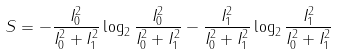<formula> <loc_0><loc_0><loc_500><loc_500>S = - \frac { I ^ { 2 } _ { 0 } } { I ^ { 2 } _ { 0 } + I ^ { 2 } _ { 1 } } \log _ { 2 } \frac { I ^ { 2 } _ { 0 } } { I ^ { 2 } _ { 0 } + I ^ { 2 } _ { 1 } } - \frac { I ^ { 2 } _ { 1 } } { I ^ { 2 } _ { 0 } + I ^ { 2 } _ { 1 } } \log _ { 2 } \frac { I ^ { 2 } _ { 1 } } { I ^ { 2 } _ { 0 } + I ^ { 2 } _ { 1 } }</formula> 